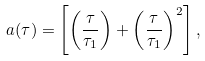<formula> <loc_0><loc_0><loc_500><loc_500>a ( \tau ) = \left [ \left ( \frac { \tau } { \tau _ { 1 } } \right ) + \left ( \frac { \tau } { \tau _ { 1 } } \right ) ^ { 2 } \right ] ,</formula> 